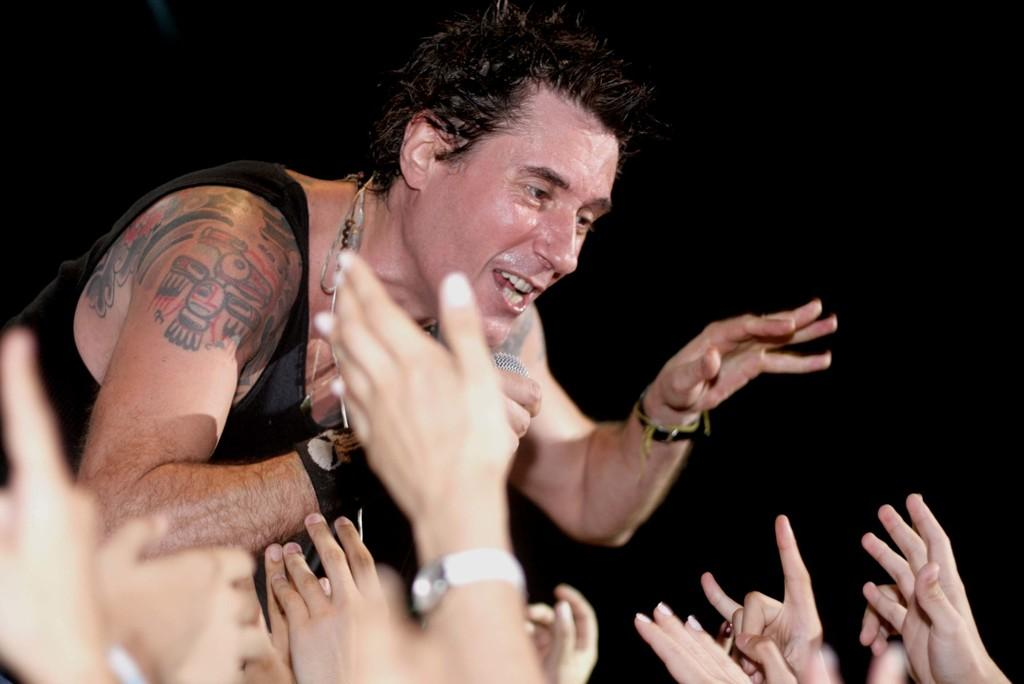What can be seen at the bottom of the image? There are hands of people at the bottom of the image. What is the main subject in the center of the image? There is a person at the center of the image. What type of cart is being pushed by the person in the image? There is no cart present in the image; it only shows hands of people at the bottom and a person at the center. What color is the button on the person's shirt in the image? There is no button mentioned or visible in the image. 